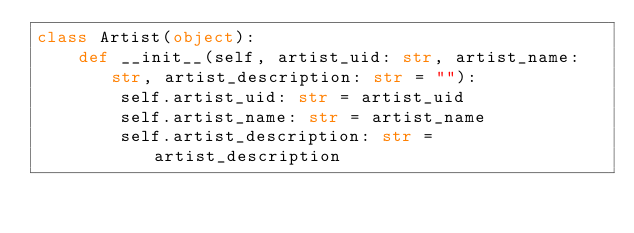Convert code to text. <code><loc_0><loc_0><loc_500><loc_500><_Python_>class Artist(object):
    def __init__(self, artist_uid: str, artist_name: str, artist_description: str = ""):
        self.artist_uid: str = artist_uid
        self.artist_name: str = artist_name
        self.artist_description: str = artist_description
</code> 